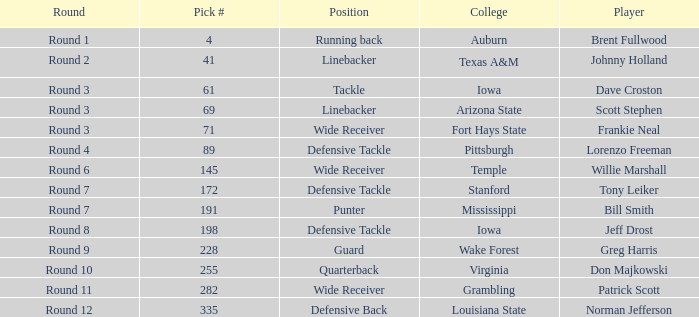What was the pick# for Lorenzo Freeman as defensive tackle? 89.0. 